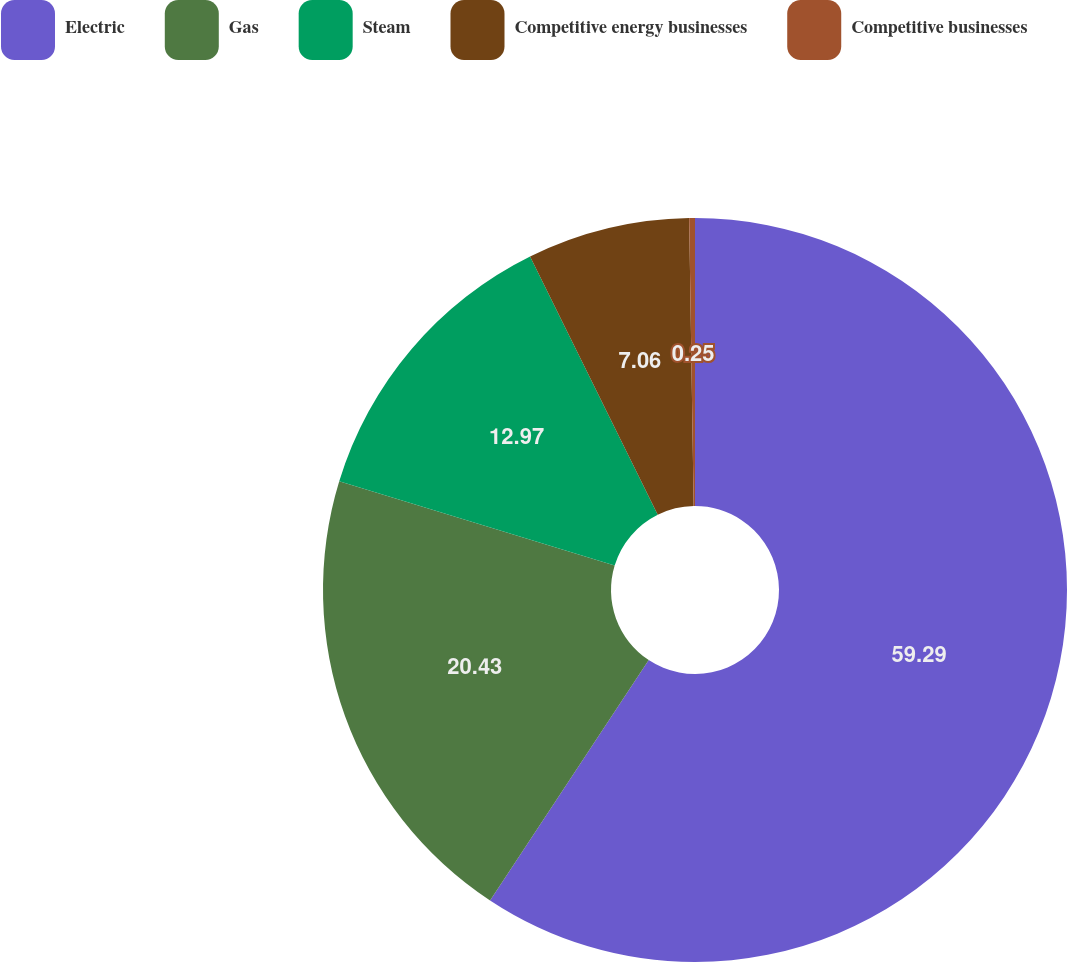Convert chart to OTSL. <chart><loc_0><loc_0><loc_500><loc_500><pie_chart><fcel>Electric<fcel>Gas<fcel>Steam<fcel>Competitive energy businesses<fcel>Competitive businesses<nl><fcel>59.28%<fcel>20.43%<fcel>12.97%<fcel>7.06%<fcel>0.25%<nl></chart> 